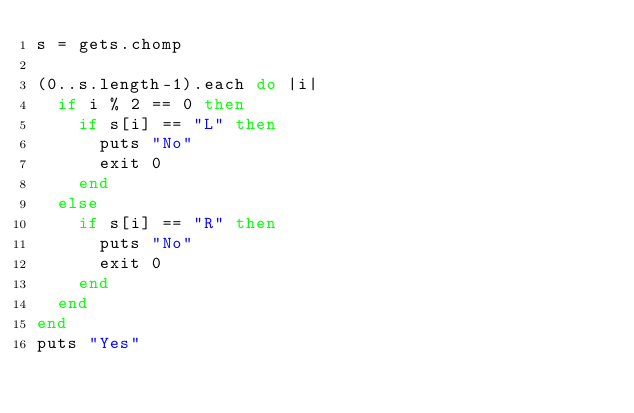Convert code to text. <code><loc_0><loc_0><loc_500><loc_500><_Ruby_>s = gets.chomp

(0..s.length-1).each do |i|
  if i % 2 == 0 then
    if s[i] == "L" then
      puts "No"
      exit 0
    end
  else
    if s[i] == "R" then
      puts "No"
      exit 0
    end
  end
end
puts "Yes"
</code> 